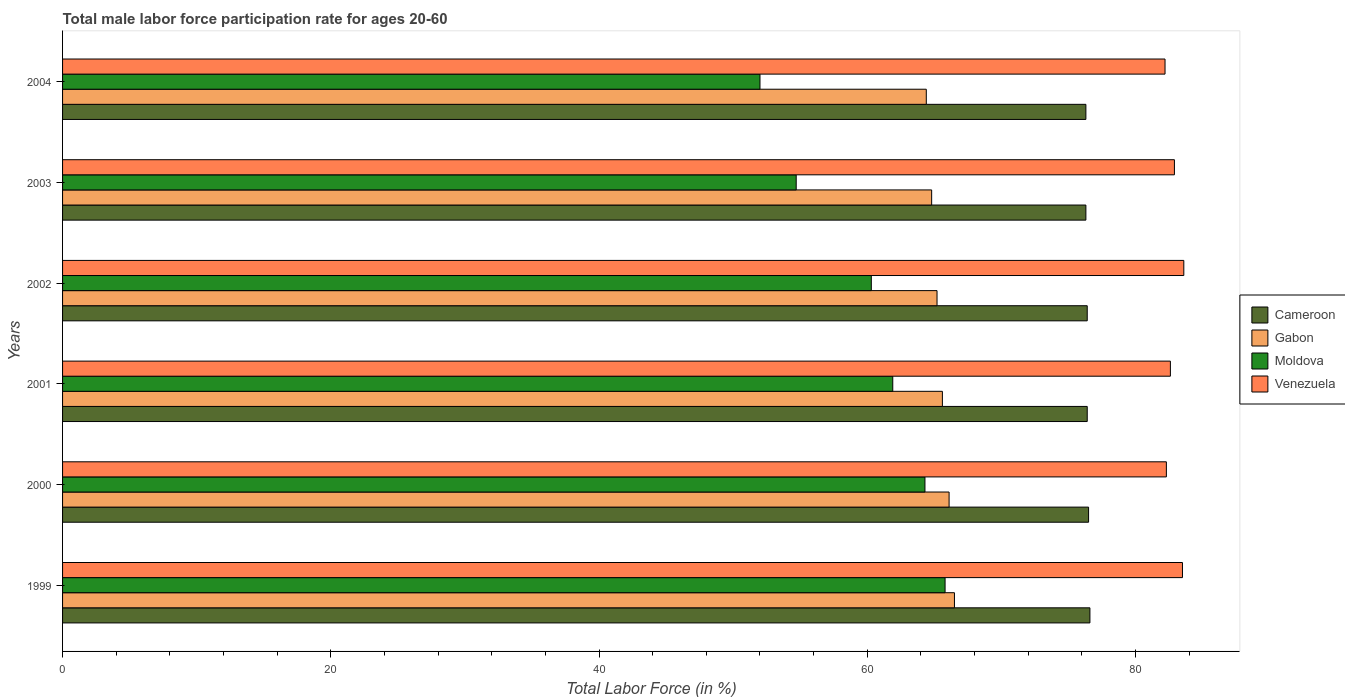How many different coloured bars are there?
Your response must be concise. 4. Are the number of bars per tick equal to the number of legend labels?
Provide a short and direct response. Yes. Are the number of bars on each tick of the Y-axis equal?
Provide a short and direct response. Yes. How many bars are there on the 2nd tick from the top?
Provide a short and direct response. 4. What is the label of the 5th group of bars from the top?
Make the answer very short. 2000. What is the male labor force participation rate in Moldova in 2003?
Your answer should be very brief. 54.7. Across all years, what is the maximum male labor force participation rate in Gabon?
Provide a succinct answer. 66.5. What is the total male labor force participation rate in Cameroon in the graph?
Provide a succinct answer. 458.5. What is the difference between the male labor force participation rate in Cameroon in 1999 and that in 2003?
Provide a short and direct response. 0.3. What is the difference between the male labor force participation rate in Gabon in 2000 and the male labor force participation rate in Moldova in 1999?
Make the answer very short. 0.3. What is the average male labor force participation rate in Cameroon per year?
Ensure brevity in your answer.  76.42. In how many years, is the male labor force participation rate in Venezuela greater than 32 %?
Keep it short and to the point. 6. What is the ratio of the male labor force participation rate in Venezuela in 2001 to that in 2002?
Provide a succinct answer. 0.99. Is the male labor force participation rate in Cameroon in 2001 less than that in 2002?
Your answer should be compact. No. What is the difference between the highest and the second highest male labor force participation rate in Cameroon?
Provide a short and direct response. 0.1. What is the difference between the highest and the lowest male labor force participation rate in Venezuela?
Keep it short and to the point. 1.4. In how many years, is the male labor force participation rate in Moldova greater than the average male labor force participation rate in Moldova taken over all years?
Give a very brief answer. 4. Is the sum of the male labor force participation rate in Moldova in 2000 and 2001 greater than the maximum male labor force participation rate in Gabon across all years?
Offer a terse response. Yes. Is it the case that in every year, the sum of the male labor force participation rate in Gabon and male labor force participation rate in Venezuela is greater than the sum of male labor force participation rate in Cameroon and male labor force participation rate in Moldova?
Your answer should be very brief. Yes. What does the 2nd bar from the top in 2000 represents?
Keep it short and to the point. Moldova. What does the 2nd bar from the bottom in 2003 represents?
Give a very brief answer. Gabon. How many bars are there?
Your answer should be very brief. 24. What is the difference between two consecutive major ticks on the X-axis?
Keep it short and to the point. 20. Where does the legend appear in the graph?
Provide a succinct answer. Center right. How many legend labels are there?
Offer a very short reply. 4. How are the legend labels stacked?
Your response must be concise. Vertical. What is the title of the graph?
Ensure brevity in your answer.  Total male labor force participation rate for ages 20-60. Does "Armenia" appear as one of the legend labels in the graph?
Provide a succinct answer. No. What is the label or title of the Y-axis?
Your answer should be compact. Years. What is the Total Labor Force (in %) of Cameroon in 1999?
Provide a succinct answer. 76.6. What is the Total Labor Force (in %) in Gabon in 1999?
Make the answer very short. 66.5. What is the Total Labor Force (in %) of Moldova in 1999?
Offer a terse response. 65.8. What is the Total Labor Force (in %) in Venezuela in 1999?
Your answer should be compact. 83.5. What is the Total Labor Force (in %) in Cameroon in 2000?
Make the answer very short. 76.5. What is the Total Labor Force (in %) in Gabon in 2000?
Your answer should be compact. 66.1. What is the Total Labor Force (in %) of Moldova in 2000?
Your response must be concise. 64.3. What is the Total Labor Force (in %) of Venezuela in 2000?
Ensure brevity in your answer.  82.3. What is the Total Labor Force (in %) in Cameroon in 2001?
Provide a short and direct response. 76.4. What is the Total Labor Force (in %) in Gabon in 2001?
Your answer should be compact. 65.6. What is the Total Labor Force (in %) of Moldova in 2001?
Offer a terse response. 61.9. What is the Total Labor Force (in %) of Venezuela in 2001?
Give a very brief answer. 82.6. What is the Total Labor Force (in %) in Cameroon in 2002?
Give a very brief answer. 76.4. What is the Total Labor Force (in %) in Gabon in 2002?
Provide a short and direct response. 65.2. What is the Total Labor Force (in %) of Moldova in 2002?
Keep it short and to the point. 60.3. What is the Total Labor Force (in %) in Venezuela in 2002?
Ensure brevity in your answer.  83.6. What is the Total Labor Force (in %) of Cameroon in 2003?
Your response must be concise. 76.3. What is the Total Labor Force (in %) of Gabon in 2003?
Your answer should be very brief. 64.8. What is the Total Labor Force (in %) in Moldova in 2003?
Your response must be concise. 54.7. What is the Total Labor Force (in %) of Venezuela in 2003?
Give a very brief answer. 82.9. What is the Total Labor Force (in %) of Cameroon in 2004?
Give a very brief answer. 76.3. What is the Total Labor Force (in %) in Gabon in 2004?
Your answer should be very brief. 64.4. What is the Total Labor Force (in %) in Moldova in 2004?
Ensure brevity in your answer.  52. What is the Total Labor Force (in %) in Venezuela in 2004?
Keep it short and to the point. 82.2. Across all years, what is the maximum Total Labor Force (in %) of Cameroon?
Your response must be concise. 76.6. Across all years, what is the maximum Total Labor Force (in %) in Gabon?
Keep it short and to the point. 66.5. Across all years, what is the maximum Total Labor Force (in %) in Moldova?
Offer a very short reply. 65.8. Across all years, what is the maximum Total Labor Force (in %) in Venezuela?
Keep it short and to the point. 83.6. Across all years, what is the minimum Total Labor Force (in %) of Cameroon?
Your response must be concise. 76.3. Across all years, what is the minimum Total Labor Force (in %) of Gabon?
Your answer should be very brief. 64.4. Across all years, what is the minimum Total Labor Force (in %) in Moldova?
Your answer should be compact. 52. Across all years, what is the minimum Total Labor Force (in %) of Venezuela?
Your answer should be very brief. 82.2. What is the total Total Labor Force (in %) of Cameroon in the graph?
Ensure brevity in your answer.  458.5. What is the total Total Labor Force (in %) in Gabon in the graph?
Your response must be concise. 392.6. What is the total Total Labor Force (in %) of Moldova in the graph?
Provide a succinct answer. 359. What is the total Total Labor Force (in %) of Venezuela in the graph?
Your response must be concise. 497.1. What is the difference between the Total Labor Force (in %) in Cameroon in 1999 and that in 2000?
Provide a succinct answer. 0.1. What is the difference between the Total Labor Force (in %) in Gabon in 1999 and that in 2000?
Provide a succinct answer. 0.4. What is the difference between the Total Labor Force (in %) of Venezuela in 1999 and that in 2001?
Ensure brevity in your answer.  0.9. What is the difference between the Total Labor Force (in %) of Moldova in 1999 and that in 2003?
Your answer should be compact. 11.1. What is the difference between the Total Labor Force (in %) of Venezuela in 1999 and that in 2003?
Provide a short and direct response. 0.6. What is the difference between the Total Labor Force (in %) of Cameroon in 1999 and that in 2004?
Offer a terse response. 0.3. What is the difference between the Total Labor Force (in %) in Gabon in 1999 and that in 2004?
Offer a terse response. 2.1. What is the difference between the Total Labor Force (in %) in Moldova in 1999 and that in 2004?
Make the answer very short. 13.8. What is the difference between the Total Labor Force (in %) of Cameroon in 2000 and that in 2001?
Keep it short and to the point. 0.1. What is the difference between the Total Labor Force (in %) of Gabon in 2000 and that in 2001?
Provide a short and direct response. 0.5. What is the difference between the Total Labor Force (in %) in Moldova in 2000 and that in 2001?
Offer a very short reply. 2.4. What is the difference between the Total Labor Force (in %) of Cameroon in 2000 and that in 2002?
Offer a terse response. 0.1. What is the difference between the Total Labor Force (in %) of Gabon in 2000 and that in 2003?
Ensure brevity in your answer.  1.3. What is the difference between the Total Labor Force (in %) of Cameroon in 2000 and that in 2004?
Your response must be concise. 0.2. What is the difference between the Total Labor Force (in %) of Gabon in 2000 and that in 2004?
Offer a very short reply. 1.7. What is the difference between the Total Labor Force (in %) of Moldova in 2000 and that in 2004?
Keep it short and to the point. 12.3. What is the difference between the Total Labor Force (in %) in Venezuela in 2000 and that in 2004?
Provide a succinct answer. 0.1. What is the difference between the Total Labor Force (in %) in Cameroon in 2001 and that in 2002?
Your answer should be very brief. 0. What is the difference between the Total Labor Force (in %) of Gabon in 2001 and that in 2002?
Keep it short and to the point. 0.4. What is the difference between the Total Labor Force (in %) of Cameroon in 2001 and that in 2003?
Give a very brief answer. 0.1. What is the difference between the Total Labor Force (in %) in Venezuela in 2001 and that in 2003?
Your response must be concise. -0.3. What is the difference between the Total Labor Force (in %) of Moldova in 2001 and that in 2004?
Your response must be concise. 9.9. What is the difference between the Total Labor Force (in %) of Venezuela in 2001 and that in 2004?
Ensure brevity in your answer.  0.4. What is the difference between the Total Labor Force (in %) of Gabon in 2002 and that in 2003?
Keep it short and to the point. 0.4. What is the difference between the Total Labor Force (in %) in Moldova in 2002 and that in 2003?
Make the answer very short. 5.6. What is the difference between the Total Labor Force (in %) in Venezuela in 2002 and that in 2003?
Your response must be concise. 0.7. What is the difference between the Total Labor Force (in %) of Cameroon in 2002 and that in 2004?
Give a very brief answer. 0.1. What is the difference between the Total Labor Force (in %) of Gabon in 2002 and that in 2004?
Provide a succinct answer. 0.8. What is the difference between the Total Labor Force (in %) in Gabon in 2003 and that in 2004?
Your response must be concise. 0.4. What is the difference between the Total Labor Force (in %) of Cameroon in 1999 and the Total Labor Force (in %) of Gabon in 2000?
Your response must be concise. 10.5. What is the difference between the Total Labor Force (in %) of Cameroon in 1999 and the Total Labor Force (in %) of Moldova in 2000?
Provide a succinct answer. 12.3. What is the difference between the Total Labor Force (in %) of Cameroon in 1999 and the Total Labor Force (in %) of Venezuela in 2000?
Provide a succinct answer. -5.7. What is the difference between the Total Labor Force (in %) of Gabon in 1999 and the Total Labor Force (in %) of Moldova in 2000?
Keep it short and to the point. 2.2. What is the difference between the Total Labor Force (in %) of Gabon in 1999 and the Total Labor Force (in %) of Venezuela in 2000?
Ensure brevity in your answer.  -15.8. What is the difference between the Total Labor Force (in %) in Moldova in 1999 and the Total Labor Force (in %) in Venezuela in 2000?
Provide a succinct answer. -16.5. What is the difference between the Total Labor Force (in %) of Gabon in 1999 and the Total Labor Force (in %) of Venezuela in 2001?
Offer a terse response. -16.1. What is the difference between the Total Labor Force (in %) in Moldova in 1999 and the Total Labor Force (in %) in Venezuela in 2001?
Your answer should be compact. -16.8. What is the difference between the Total Labor Force (in %) of Cameroon in 1999 and the Total Labor Force (in %) of Gabon in 2002?
Your response must be concise. 11.4. What is the difference between the Total Labor Force (in %) in Cameroon in 1999 and the Total Labor Force (in %) in Moldova in 2002?
Give a very brief answer. 16.3. What is the difference between the Total Labor Force (in %) of Cameroon in 1999 and the Total Labor Force (in %) of Venezuela in 2002?
Make the answer very short. -7. What is the difference between the Total Labor Force (in %) in Gabon in 1999 and the Total Labor Force (in %) in Moldova in 2002?
Offer a terse response. 6.2. What is the difference between the Total Labor Force (in %) of Gabon in 1999 and the Total Labor Force (in %) of Venezuela in 2002?
Offer a very short reply. -17.1. What is the difference between the Total Labor Force (in %) in Moldova in 1999 and the Total Labor Force (in %) in Venezuela in 2002?
Offer a very short reply. -17.8. What is the difference between the Total Labor Force (in %) in Cameroon in 1999 and the Total Labor Force (in %) in Moldova in 2003?
Your answer should be compact. 21.9. What is the difference between the Total Labor Force (in %) of Cameroon in 1999 and the Total Labor Force (in %) of Venezuela in 2003?
Your answer should be compact. -6.3. What is the difference between the Total Labor Force (in %) in Gabon in 1999 and the Total Labor Force (in %) in Venezuela in 2003?
Provide a succinct answer. -16.4. What is the difference between the Total Labor Force (in %) in Moldova in 1999 and the Total Labor Force (in %) in Venezuela in 2003?
Provide a short and direct response. -17.1. What is the difference between the Total Labor Force (in %) of Cameroon in 1999 and the Total Labor Force (in %) of Moldova in 2004?
Your answer should be compact. 24.6. What is the difference between the Total Labor Force (in %) of Gabon in 1999 and the Total Labor Force (in %) of Moldova in 2004?
Offer a very short reply. 14.5. What is the difference between the Total Labor Force (in %) of Gabon in 1999 and the Total Labor Force (in %) of Venezuela in 2004?
Provide a succinct answer. -15.7. What is the difference between the Total Labor Force (in %) in Moldova in 1999 and the Total Labor Force (in %) in Venezuela in 2004?
Offer a terse response. -16.4. What is the difference between the Total Labor Force (in %) in Cameroon in 2000 and the Total Labor Force (in %) in Gabon in 2001?
Your answer should be very brief. 10.9. What is the difference between the Total Labor Force (in %) of Cameroon in 2000 and the Total Labor Force (in %) of Moldova in 2001?
Your answer should be very brief. 14.6. What is the difference between the Total Labor Force (in %) of Gabon in 2000 and the Total Labor Force (in %) of Moldova in 2001?
Keep it short and to the point. 4.2. What is the difference between the Total Labor Force (in %) of Gabon in 2000 and the Total Labor Force (in %) of Venezuela in 2001?
Provide a succinct answer. -16.5. What is the difference between the Total Labor Force (in %) in Moldova in 2000 and the Total Labor Force (in %) in Venezuela in 2001?
Your response must be concise. -18.3. What is the difference between the Total Labor Force (in %) of Cameroon in 2000 and the Total Labor Force (in %) of Moldova in 2002?
Give a very brief answer. 16.2. What is the difference between the Total Labor Force (in %) of Cameroon in 2000 and the Total Labor Force (in %) of Venezuela in 2002?
Provide a succinct answer. -7.1. What is the difference between the Total Labor Force (in %) in Gabon in 2000 and the Total Labor Force (in %) in Moldova in 2002?
Your response must be concise. 5.8. What is the difference between the Total Labor Force (in %) in Gabon in 2000 and the Total Labor Force (in %) in Venezuela in 2002?
Ensure brevity in your answer.  -17.5. What is the difference between the Total Labor Force (in %) of Moldova in 2000 and the Total Labor Force (in %) of Venezuela in 2002?
Your answer should be very brief. -19.3. What is the difference between the Total Labor Force (in %) in Cameroon in 2000 and the Total Labor Force (in %) in Gabon in 2003?
Offer a very short reply. 11.7. What is the difference between the Total Labor Force (in %) of Cameroon in 2000 and the Total Labor Force (in %) of Moldova in 2003?
Ensure brevity in your answer.  21.8. What is the difference between the Total Labor Force (in %) in Cameroon in 2000 and the Total Labor Force (in %) in Venezuela in 2003?
Offer a terse response. -6.4. What is the difference between the Total Labor Force (in %) of Gabon in 2000 and the Total Labor Force (in %) of Moldova in 2003?
Keep it short and to the point. 11.4. What is the difference between the Total Labor Force (in %) in Gabon in 2000 and the Total Labor Force (in %) in Venezuela in 2003?
Give a very brief answer. -16.8. What is the difference between the Total Labor Force (in %) of Moldova in 2000 and the Total Labor Force (in %) of Venezuela in 2003?
Provide a succinct answer. -18.6. What is the difference between the Total Labor Force (in %) in Cameroon in 2000 and the Total Labor Force (in %) in Venezuela in 2004?
Ensure brevity in your answer.  -5.7. What is the difference between the Total Labor Force (in %) in Gabon in 2000 and the Total Labor Force (in %) in Venezuela in 2004?
Give a very brief answer. -16.1. What is the difference between the Total Labor Force (in %) in Moldova in 2000 and the Total Labor Force (in %) in Venezuela in 2004?
Your response must be concise. -17.9. What is the difference between the Total Labor Force (in %) of Cameroon in 2001 and the Total Labor Force (in %) of Gabon in 2002?
Ensure brevity in your answer.  11.2. What is the difference between the Total Labor Force (in %) in Cameroon in 2001 and the Total Labor Force (in %) in Moldova in 2002?
Ensure brevity in your answer.  16.1. What is the difference between the Total Labor Force (in %) of Moldova in 2001 and the Total Labor Force (in %) of Venezuela in 2002?
Give a very brief answer. -21.7. What is the difference between the Total Labor Force (in %) of Cameroon in 2001 and the Total Labor Force (in %) of Moldova in 2003?
Provide a succinct answer. 21.7. What is the difference between the Total Labor Force (in %) in Cameroon in 2001 and the Total Labor Force (in %) in Venezuela in 2003?
Give a very brief answer. -6.5. What is the difference between the Total Labor Force (in %) in Gabon in 2001 and the Total Labor Force (in %) in Venezuela in 2003?
Your answer should be very brief. -17.3. What is the difference between the Total Labor Force (in %) in Cameroon in 2001 and the Total Labor Force (in %) in Gabon in 2004?
Provide a succinct answer. 12. What is the difference between the Total Labor Force (in %) in Cameroon in 2001 and the Total Labor Force (in %) in Moldova in 2004?
Your answer should be very brief. 24.4. What is the difference between the Total Labor Force (in %) of Gabon in 2001 and the Total Labor Force (in %) of Venezuela in 2004?
Your answer should be very brief. -16.6. What is the difference between the Total Labor Force (in %) of Moldova in 2001 and the Total Labor Force (in %) of Venezuela in 2004?
Provide a short and direct response. -20.3. What is the difference between the Total Labor Force (in %) of Cameroon in 2002 and the Total Labor Force (in %) of Moldova in 2003?
Your answer should be compact. 21.7. What is the difference between the Total Labor Force (in %) of Gabon in 2002 and the Total Labor Force (in %) of Moldova in 2003?
Your response must be concise. 10.5. What is the difference between the Total Labor Force (in %) in Gabon in 2002 and the Total Labor Force (in %) in Venezuela in 2003?
Your answer should be compact. -17.7. What is the difference between the Total Labor Force (in %) in Moldova in 2002 and the Total Labor Force (in %) in Venezuela in 2003?
Make the answer very short. -22.6. What is the difference between the Total Labor Force (in %) of Cameroon in 2002 and the Total Labor Force (in %) of Gabon in 2004?
Keep it short and to the point. 12. What is the difference between the Total Labor Force (in %) of Cameroon in 2002 and the Total Labor Force (in %) of Moldova in 2004?
Keep it short and to the point. 24.4. What is the difference between the Total Labor Force (in %) of Gabon in 2002 and the Total Labor Force (in %) of Moldova in 2004?
Ensure brevity in your answer.  13.2. What is the difference between the Total Labor Force (in %) in Moldova in 2002 and the Total Labor Force (in %) in Venezuela in 2004?
Keep it short and to the point. -21.9. What is the difference between the Total Labor Force (in %) in Cameroon in 2003 and the Total Labor Force (in %) in Gabon in 2004?
Provide a short and direct response. 11.9. What is the difference between the Total Labor Force (in %) of Cameroon in 2003 and the Total Labor Force (in %) of Moldova in 2004?
Your response must be concise. 24.3. What is the difference between the Total Labor Force (in %) of Cameroon in 2003 and the Total Labor Force (in %) of Venezuela in 2004?
Offer a very short reply. -5.9. What is the difference between the Total Labor Force (in %) in Gabon in 2003 and the Total Labor Force (in %) in Moldova in 2004?
Ensure brevity in your answer.  12.8. What is the difference between the Total Labor Force (in %) in Gabon in 2003 and the Total Labor Force (in %) in Venezuela in 2004?
Provide a short and direct response. -17.4. What is the difference between the Total Labor Force (in %) in Moldova in 2003 and the Total Labor Force (in %) in Venezuela in 2004?
Offer a very short reply. -27.5. What is the average Total Labor Force (in %) of Cameroon per year?
Provide a short and direct response. 76.42. What is the average Total Labor Force (in %) of Gabon per year?
Give a very brief answer. 65.43. What is the average Total Labor Force (in %) in Moldova per year?
Provide a succinct answer. 59.83. What is the average Total Labor Force (in %) in Venezuela per year?
Offer a terse response. 82.85. In the year 1999, what is the difference between the Total Labor Force (in %) in Cameroon and Total Labor Force (in %) in Gabon?
Make the answer very short. 10.1. In the year 1999, what is the difference between the Total Labor Force (in %) of Cameroon and Total Labor Force (in %) of Venezuela?
Ensure brevity in your answer.  -6.9. In the year 1999, what is the difference between the Total Labor Force (in %) of Gabon and Total Labor Force (in %) of Moldova?
Offer a very short reply. 0.7. In the year 1999, what is the difference between the Total Labor Force (in %) in Moldova and Total Labor Force (in %) in Venezuela?
Make the answer very short. -17.7. In the year 2000, what is the difference between the Total Labor Force (in %) in Cameroon and Total Labor Force (in %) in Venezuela?
Your answer should be very brief. -5.8. In the year 2000, what is the difference between the Total Labor Force (in %) in Gabon and Total Labor Force (in %) in Moldova?
Give a very brief answer. 1.8. In the year 2000, what is the difference between the Total Labor Force (in %) of Gabon and Total Labor Force (in %) of Venezuela?
Offer a terse response. -16.2. In the year 2000, what is the difference between the Total Labor Force (in %) of Moldova and Total Labor Force (in %) of Venezuela?
Provide a short and direct response. -18. In the year 2001, what is the difference between the Total Labor Force (in %) in Cameroon and Total Labor Force (in %) in Venezuela?
Keep it short and to the point. -6.2. In the year 2001, what is the difference between the Total Labor Force (in %) in Gabon and Total Labor Force (in %) in Moldova?
Ensure brevity in your answer.  3.7. In the year 2001, what is the difference between the Total Labor Force (in %) of Gabon and Total Labor Force (in %) of Venezuela?
Your answer should be compact. -17. In the year 2001, what is the difference between the Total Labor Force (in %) in Moldova and Total Labor Force (in %) in Venezuela?
Your response must be concise. -20.7. In the year 2002, what is the difference between the Total Labor Force (in %) in Cameroon and Total Labor Force (in %) in Venezuela?
Your answer should be compact. -7.2. In the year 2002, what is the difference between the Total Labor Force (in %) in Gabon and Total Labor Force (in %) in Venezuela?
Your answer should be very brief. -18.4. In the year 2002, what is the difference between the Total Labor Force (in %) of Moldova and Total Labor Force (in %) of Venezuela?
Give a very brief answer. -23.3. In the year 2003, what is the difference between the Total Labor Force (in %) of Cameroon and Total Labor Force (in %) of Moldova?
Your answer should be compact. 21.6. In the year 2003, what is the difference between the Total Labor Force (in %) of Gabon and Total Labor Force (in %) of Moldova?
Provide a succinct answer. 10.1. In the year 2003, what is the difference between the Total Labor Force (in %) in Gabon and Total Labor Force (in %) in Venezuela?
Your response must be concise. -18.1. In the year 2003, what is the difference between the Total Labor Force (in %) of Moldova and Total Labor Force (in %) of Venezuela?
Provide a succinct answer. -28.2. In the year 2004, what is the difference between the Total Labor Force (in %) in Cameroon and Total Labor Force (in %) in Gabon?
Ensure brevity in your answer.  11.9. In the year 2004, what is the difference between the Total Labor Force (in %) in Cameroon and Total Labor Force (in %) in Moldova?
Your answer should be very brief. 24.3. In the year 2004, what is the difference between the Total Labor Force (in %) of Cameroon and Total Labor Force (in %) of Venezuela?
Offer a very short reply. -5.9. In the year 2004, what is the difference between the Total Labor Force (in %) of Gabon and Total Labor Force (in %) of Moldova?
Offer a terse response. 12.4. In the year 2004, what is the difference between the Total Labor Force (in %) in Gabon and Total Labor Force (in %) in Venezuela?
Provide a short and direct response. -17.8. In the year 2004, what is the difference between the Total Labor Force (in %) of Moldova and Total Labor Force (in %) of Venezuela?
Your response must be concise. -30.2. What is the ratio of the Total Labor Force (in %) of Cameroon in 1999 to that in 2000?
Offer a terse response. 1. What is the ratio of the Total Labor Force (in %) in Gabon in 1999 to that in 2000?
Make the answer very short. 1.01. What is the ratio of the Total Labor Force (in %) of Moldova in 1999 to that in 2000?
Keep it short and to the point. 1.02. What is the ratio of the Total Labor Force (in %) in Venezuela in 1999 to that in 2000?
Your response must be concise. 1.01. What is the ratio of the Total Labor Force (in %) in Gabon in 1999 to that in 2001?
Make the answer very short. 1.01. What is the ratio of the Total Labor Force (in %) in Moldova in 1999 to that in 2001?
Your response must be concise. 1.06. What is the ratio of the Total Labor Force (in %) in Venezuela in 1999 to that in 2001?
Ensure brevity in your answer.  1.01. What is the ratio of the Total Labor Force (in %) of Cameroon in 1999 to that in 2002?
Your answer should be very brief. 1. What is the ratio of the Total Labor Force (in %) in Gabon in 1999 to that in 2002?
Offer a very short reply. 1.02. What is the ratio of the Total Labor Force (in %) in Moldova in 1999 to that in 2002?
Provide a short and direct response. 1.09. What is the ratio of the Total Labor Force (in %) of Venezuela in 1999 to that in 2002?
Your answer should be very brief. 1. What is the ratio of the Total Labor Force (in %) of Gabon in 1999 to that in 2003?
Make the answer very short. 1.03. What is the ratio of the Total Labor Force (in %) of Moldova in 1999 to that in 2003?
Your answer should be very brief. 1.2. What is the ratio of the Total Labor Force (in %) in Gabon in 1999 to that in 2004?
Keep it short and to the point. 1.03. What is the ratio of the Total Labor Force (in %) of Moldova in 1999 to that in 2004?
Ensure brevity in your answer.  1.27. What is the ratio of the Total Labor Force (in %) in Venezuela in 1999 to that in 2004?
Your answer should be very brief. 1.02. What is the ratio of the Total Labor Force (in %) in Gabon in 2000 to that in 2001?
Provide a succinct answer. 1.01. What is the ratio of the Total Labor Force (in %) of Moldova in 2000 to that in 2001?
Your response must be concise. 1.04. What is the ratio of the Total Labor Force (in %) in Gabon in 2000 to that in 2002?
Offer a terse response. 1.01. What is the ratio of the Total Labor Force (in %) of Moldova in 2000 to that in 2002?
Your answer should be compact. 1.07. What is the ratio of the Total Labor Force (in %) in Venezuela in 2000 to that in 2002?
Keep it short and to the point. 0.98. What is the ratio of the Total Labor Force (in %) in Cameroon in 2000 to that in 2003?
Offer a terse response. 1. What is the ratio of the Total Labor Force (in %) of Gabon in 2000 to that in 2003?
Offer a very short reply. 1.02. What is the ratio of the Total Labor Force (in %) in Moldova in 2000 to that in 2003?
Offer a very short reply. 1.18. What is the ratio of the Total Labor Force (in %) of Gabon in 2000 to that in 2004?
Your response must be concise. 1.03. What is the ratio of the Total Labor Force (in %) in Moldova in 2000 to that in 2004?
Your answer should be very brief. 1.24. What is the ratio of the Total Labor Force (in %) in Venezuela in 2000 to that in 2004?
Provide a short and direct response. 1. What is the ratio of the Total Labor Force (in %) in Gabon in 2001 to that in 2002?
Give a very brief answer. 1.01. What is the ratio of the Total Labor Force (in %) in Moldova in 2001 to that in 2002?
Offer a very short reply. 1.03. What is the ratio of the Total Labor Force (in %) in Venezuela in 2001 to that in 2002?
Your answer should be very brief. 0.99. What is the ratio of the Total Labor Force (in %) of Cameroon in 2001 to that in 2003?
Your answer should be compact. 1. What is the ratio of the Total Labor Force (in %) in Gabon in 2001 to that in 2003?
Make the answer very short. 1.01. What is the ratio of the Total Labor Force (in %) in Moldova in 2001 to that in 2003?
Your answer should be very brief. 1.13. What is the ratio of the Total Labor Force (in %) in Venezuela in 2001 to that in 2003?
Offer a very short reply. 1. What is the ratio of the Total Labor Force (in %) of Gabon in 2001 to that in 2004?
Give a very brief answer. 1.02. What is the ratio of the Total Labor Force (in %) of Moldova in 2001 to that in 2004?
Keep it short and to the point. 1.19. What is the ratio of the Total Labor Force (in %) in Venezuela in 2001 to that in 2004?
Ensure brevity in your answer.  1. What is the ratio of the Total Labor Force (in %) in Cameroon in 2002 to that in 2003?
Give a very brief answer. 1. What is the ratio of the Total Labor Force (in %) in Moldova in 2002 to that in 2003?
Give a very brief answer. 1.1. What is the ratio of the Total Labor Force (in %) of Venezuela in 2002 to that in 2003?
Keep it short and to the point. 1.01. What is the ratio of the Total Labor Force (in %) in Cameroon in 2002 to that in 2004?
Give a very brief answer. 1. What is the ratio of the Total Labor Force (in %) in Gabon in 2002 to that in 2004?
Your response must be concise. 1.01. What is the ratio of the Total Labor Force (in %) of Moldova in 2002 to that in 2004?
Your answer should be compact. 1.16. What is the ratio of the Total Labor Force (in %) of Gabon in 2003 to that in 2004?
Offer a very short reply. 1.01. What is the ratio of the Total Labor Force (in %) of Moldova in 2003 to that in 2004?
Your answer should be compact. 1.05. What is the ratio of the Total Labor Force (in %) of Venezuela in 2003 to that in 2004?
Give a very brief answer. 1.01. What is the difference between the highest and the second highest Total Labor Force (in %) in Gabon?
Keep it short and to the point. 0.4. What is the difference between the highest and the second highest Total Labor Force (in %) in Venezuela?
Give a very brief answer. 0.1. What is the difference between the highest and the lowest Total Labor Force (in %) in Cameroon?
Ensure brevity in your answer.  0.3. What is the difference between the highest and the lowest Total Labor Force (in %) in Gabon?
Your answer should be compact. 2.1. What is the difference between the highest and the lowest Total Labor Force (in %) in Moldova?
Your answer should be compact. 13.8. 